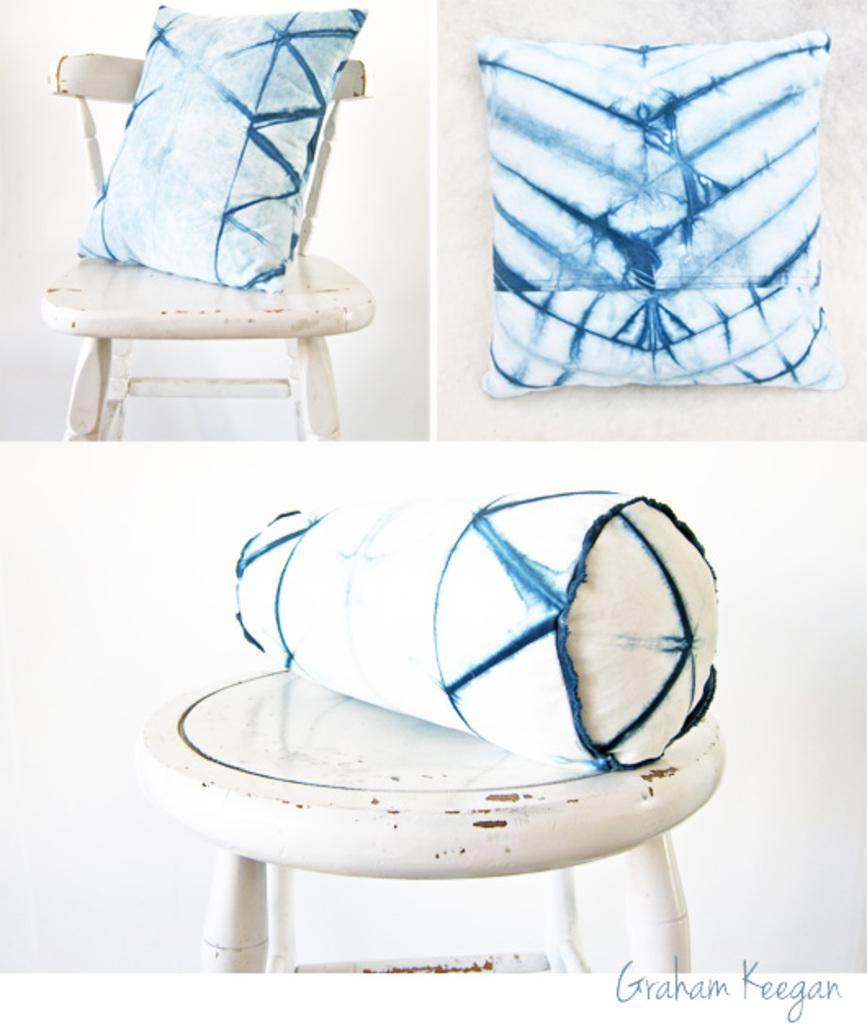What type of furniture is present in the image? There is a table in the image. Can you describe the chair in the image? There is a chair in white color in the image. What colors are the pillows in the image? The pillows in the image are in blue and white color. How many pins are attached to the chair in the image? There are no pins attached to the chair in the image. What type of bottle is placed on the table in the image? There is no bottle present on the table in the image. 